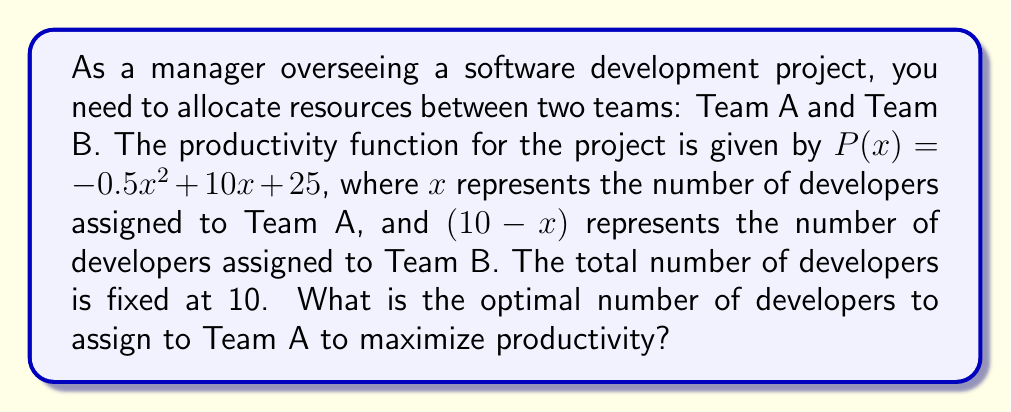Teach me how to tackle this problem. To solve this problem, we'll follow these steps:

1) The productivity function is given by $P(x) = -0.5x^2 + 10x + 25$, where $x$ is the number of developers in Team A.

2) To find the maximum value of this quadratic function, we need to find the vertex of the parabola. The x-coordinate of the vertex will give us the optimal number of developers for Team A.

3) For a quadratic function in the form $f(x) = ax^2 + bx + c$, the x-coordinate of the vertex is given by $x = -\frac{b}{2a}$.

4) In our case, $a = -0.5$ and $b = 10$. Let's substitute these values:

   $x = -\frac{10}{2(-0.5)} = -\frac{10}{-1} = 10$

5) However, we need to consider our constraint: the total number of developers is 10, so $x$ must be between 0 and 10.

6) Since our calculated $x$ is exactly 10, this satisfies our constraint.

Therefore, the optimal number of developers to assign to Team A is 10.
Answer: 10 developers 